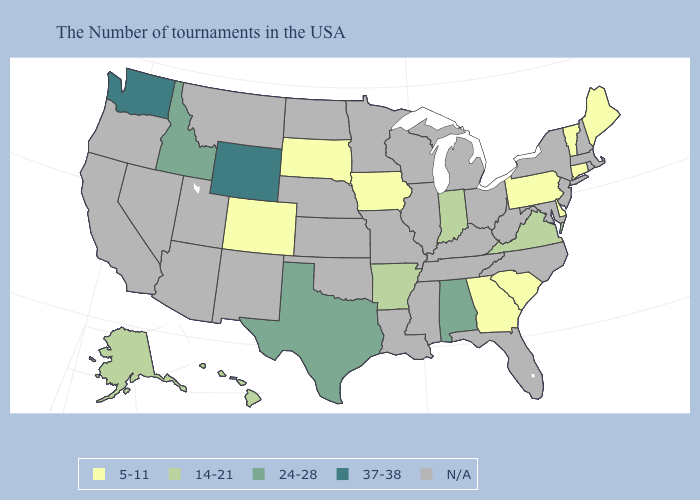Name the states that have a value in the range 14-21?
Write a very short answer. Virginia, Indiana, Arkansas, Alaska, Hawaii. Among the states that border Missouri , does Iowa have the lowest value?
Write a very short answer. Yes. Name the states that have a value in the range 5-11?
Concise answer only. Maine, Vermont, Connecticut, Delaware, Pennsylvania, South Carolina, Georgia, Iowa, South Dakota, Colorado. What is the value of South Carolina?
Keep it brief. 5-11. What is the lowest value in the South?
Write a very short answer. 5-11. Which states have the lowest value in the USA?
Short answer required. Maine, Vermont, Connecticut, Delaware, Pennsylvania, South Carolina, Georgia, Iowa, South Dakota, Colorado. Name the states that have a value in the range 24-28?
Short answer required. Alabama, Texas, Idaho. Does the first symbol in the legend represent the smallest category?
Keep it brief. Yes. What is the value of Alabama?
Write a very short answer. 24-28. Does Wyoming have the highest value in the West?
Short answer required. Yes. What is the value of Maine?
Concise answer only. 5-11. 